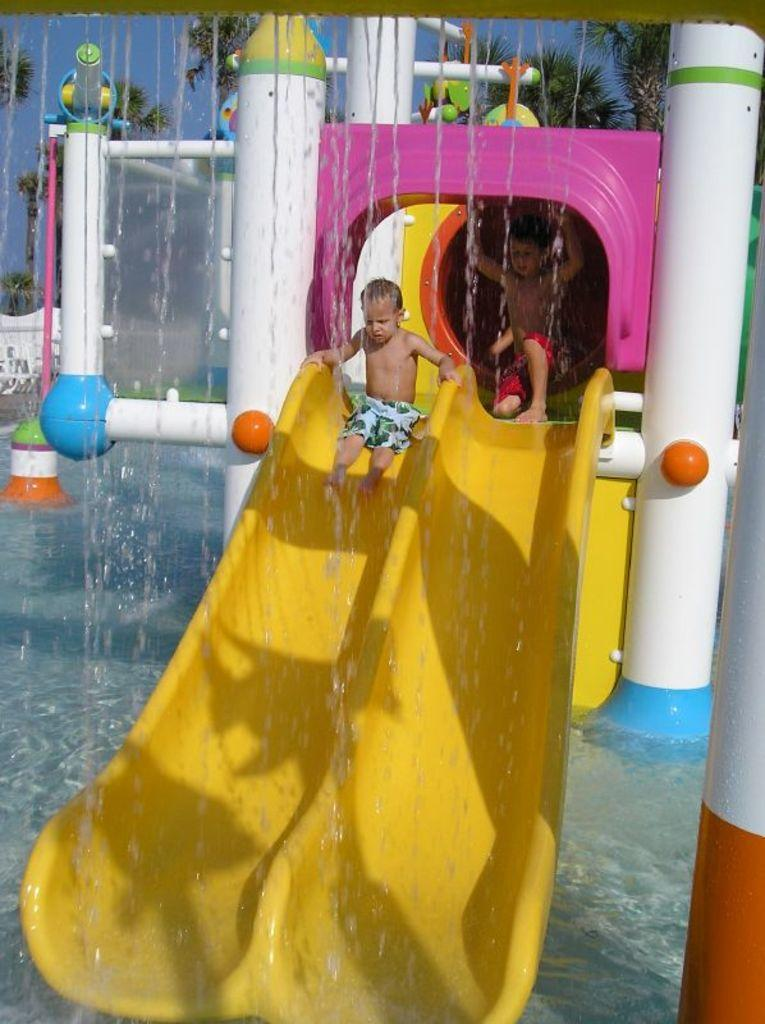What is the child in the image doing? There is a child sliding in the image. What is the other child in the image doing? There is another child sitting in the image. What can be seen in the background of the image? There is water and trees visible in the image. Where is the hose located in the image? There is no hose present in the image. What kind of trouble is the child on the slide causing in the image? The image does not depict any trouble or conflict involving the child on the slide. 